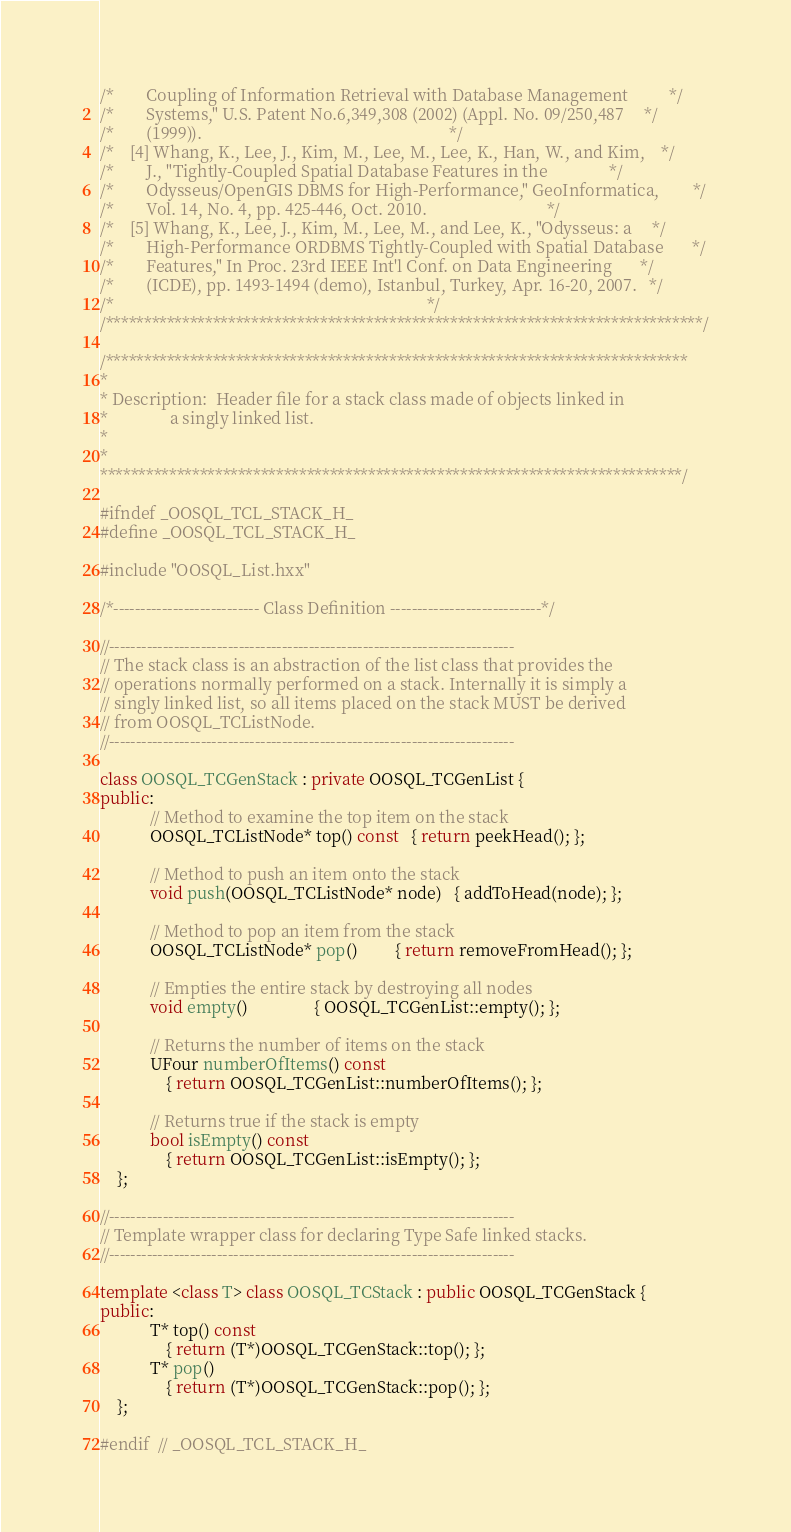Convert code to text. <code><loc_0><loc_0><loc_500><loc_500><_C++_>/*        Coupling of Information Retrieval with Database Management          */
/*        Systems," U.S. Patent No.6,349,308 (2002) (Appl. No. 09/250,487     */
/*        (1999)).                                                            */
/*    [4] Whang, K., Lee, J., Kim, M., Lee, M., Lee, K., Han, W., and Kim,    */
/*        J., "Tightly-Coupled Spatial Database Features in the               */
/*        Odysseus/OpenGIS DBMS for High-Performance," GeoInformatica,        */
/*        Vol. 14, No. 4, pp. 425-446, Oct. 2010.                             */
/*    [5] Whang, K., Lee, J., Kim, M., Lee, M., and Lee, K., "Odysseus: a     */
/*        High-Performance ORDBMS Tightly-Coupled with Spatial Database       */
/*        Features," In Proc. 23rd IEEE Int'l Conf. on Data Engineering       */
/*        (ICDE), pp. 1493-1494 (demo), Istanbul, Turkey, Apr. 16-20, 2007.   */
/*                                                                            */
/******************************************************************************/

/****************************************************************************
*
* Description:  Header file for a stack class made of objects linked in
*               a singly linked list.
*
*
****************************************************************************/

#ifndef _OOSQL_TCL_STACK_H_
#define _OOSQL_TCL_STACK_H_

#include "OOSQL_List.hxx"

/*--------------------------- Class Definition ----------------------------*/

//---------------------------------------------------------------------------
// The stack class is an abstraction of the list class that provides the
// operations normally performed on a stack. Internally it is simply a
// singly linked list, so all items placed on the stack MUST be derived
// from OOSQL_TCListNode.
//---------------------------------------------------------------------------

class OOSQL_TCGenStack : private OOSQL_TCGenList {
public:
            // Method to examine the top item on the stack
            OOSQL_TCListNode* top() const   { return peekHead(); };

            // Method to push an item onto the stack
            void push(OOSQL_TCListNode* node)   { addToHead(node); };

            // Method to pop an item from the stack
            OOSQL_TCListNode* pop()         { return removeFromHead(); };

            // Empties the entire stack by destroying all nodes
            void empty()                { OOSQL_TCGenList::empty(); };

            // Returns the number of items on the stack
            UFour numberOfItems() const
                { return OOSQL_TCGenList::numberOfItems(); };

            // Returns true if the stack is empty
            bool isEmpty() const
                { return OOSQL_TCGenList::isEmpty(); };
    };

//---------------------------------------------------------------------------
// Template wrapper class for declaring Type Safe linked stacks.
//---------------------------------------------------------------------------

template <class T> class OOSQL_TCStack : public OOSQL_TCGenStack {
public:
            T* top() const
                { return (T*)OOSQL_TCGenStack::top(); };
            T* pop()
                { return (T*)OOSQL_TCGenStack::pop(); };
    };

#endif  // _OOSQL_TCL_STACK_H_
</code> 